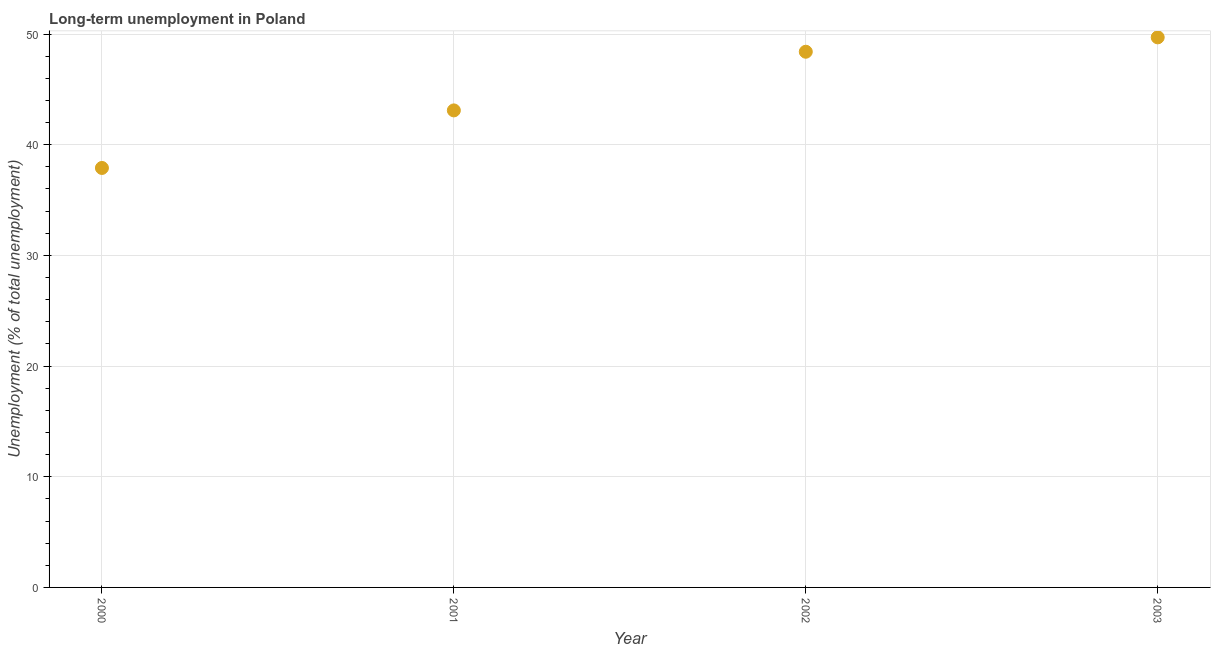What is the long-term unemployment in 2000?
Give a very brief answer. 37.9. Across all years, what is the maximum long-term unemployment?
Provide a succinct answer. 49.7. Across all years, what is the minimum long-term unemployment?
Offer a very short reply. 37.9. In which year was the long-term unemployment maximum?
Give a very brief answer. 2003. In which year was the long-term unemployment minimum?
Offer a terse response. 2000. What is the sum of the long-term unemployment?
Provide a succinct answer. 179.1. What is the difference between the long-term unemployment in 2000 and 2002?
Ensure brevity in your answer.  -10.5. What is the average long-term unemployment per year?
Your answer should be very brief. 44.78. What is the median long-term unemployment?
Offer a very short reply. 45.75. In how many years, is the long-term unemployment greater than 44 %?
Offer a very short reply. 2. Do a majority of the years between 2001 and 2003 (inclusive) have long-term unemployment greater than 40 %?
Provide a succinct answer. Yes. What is the ratio of the long-term unemployment in 2000 to that in 2002?
Your answer should be very brief. 0.78. Is the difference between the long-term unemployment in 2000 and 2003 greater than the difference between any two years?
Give a very brief answer. Yes. What is the difference between the highest and the second highest long-term unemployment?
Your response must be concise. 1.3. Is the sum of the long-term unemployment in 2001 and 2002 greater than the maximum long-term unemployment across all years?
Your answer should be compact. Yes. What is the difference between the highest and the lowest long-term unemployment?
Your response must be concise. 11.8. How many dotlines are there?
Provide a succinct answer. 1. How many years are there in the graph?
Your response must be concise. 4. What is the difference between two consecutive major ticks on the Y-axis?
Make the answer very short. 10. Are the values on the major ticks of Y-axis written in scientific E-notation?
Give a very brief answer. No. Does the graph contain grids?
Give a very brief answer. Yes. What is the title of the graph?
Ensure brevity in your answer.  Long-term unemployment in Poland. What is the label or title of the Y-axis?
Ensure brevity in your answer.  Unemployment (% of total unemployment). What is the Unemployment (% of total unemployment) in 2000?
Provide a short and direct response. 37.9. What is the Unemployment (% of total unemployment) in 2001?
Keep it short and to the point. 43.1. What is the Unemployment (% of total unemployment) in 2002?
Keep it short and to the point. 48.4. What is the Unemployment (% of total unemployment) in 2003?
Provide a succinct answer. 49.7. What is the difference between the Unemployment (% of total unemployment) in 2000 and 2002?
Ensure brevity in your answer.  -10.5. What is the difference between the Unemployment (% of total unemployment) in 2001 and 2003?
Provide a short and direct response. -6.6. What is the difference between the Unemployment (% of total unemployment) in 2002 and 2003?
Make the answer very short. -1.3. What is the ratio of the Unemployment (% of total unemployment) in 2000 to that in 2001?
Your response must be concise. 0.88. What is the ratio of the Unemployment (% of total unemployment) in 2000 to that in 2002?
Your answer should be compact. 0.78. What is the ratio of the Unemployment (% of total unemployment) in 2000 to that in 2003?
Your answer should be compact. 0.76. What is the ratio of the Unemployment (% of total unemployment) in 2001 to that in 2002?
Give a very brief answer. 0.89. What is the ratio of the Unemployment (% of total unemployment) in 2001 to that in 2003?
Give a very brief answer. 0.87. What is the ratio of the Unemployment (% of total unemployment) in 2002 to that in 2003?
Your response must be concise. 0.97. 